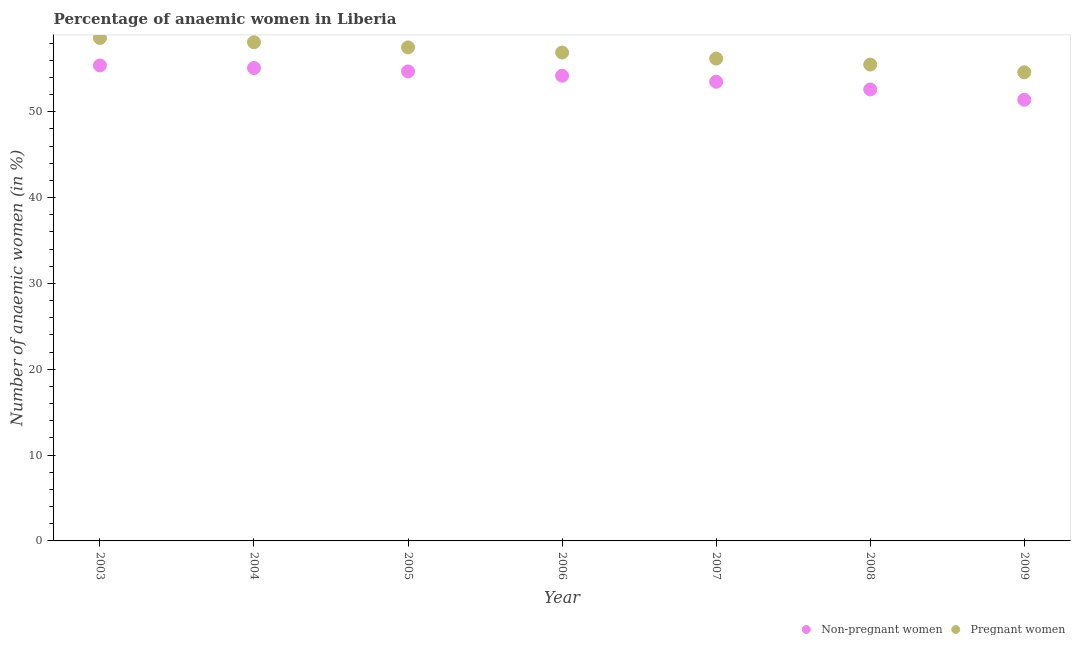How many different coloured dotlines are there?
Ensure brevity in your answer.  2. What is the percentage of pregnant anaemic women in 2003?
Provide a succinct answer. 58.6. Across all years, what is the maximum percentage of pregnant anaemic women?
Keep it short and to the point. 58.6. Across all years, what is the minimum percentage of non-pregnant anaemic women?
Your response must be concise. 51.4. What is the total percentage of pregnant anaemic women in the graph?
Offer a terse response. 397.4. What is the difference between the percentage of pregnant anaemic women in 2005 and that in 2009?
Ensure brevity in your answer.  2.9. What is the difference between the percentage of pregnant anaemic women in 2009 and the percentage of non-pregnant anaemic women in 2004?
Your answer should be very brief. -0.5. What is the average percentage of non-pregnant anaemic women per year?
Provide a succinct answer. 53.84. What is the ratio of the percentage of non-pregnant anaemic women in 2008 to that in 2009?
Provide a short and direct response. 1.02. Is the percentage of non-pregnant anaemic women in 2004 less than that in 2005?
Offer a very short reply. No. What is the difference between the highest and the second highest percentage of non-pregnant anaemic women?
Give a very brief answer. 0.3. In how many years, is the percentage of non-pregnant anaemic women greater than the average percentage of non-pregnant anaemic women taken over all years?
Keep it short and to the point. 4. Is the sum of the percentage of non-pregnant anaemic women in 2005 and 2008 greater than the maximum percentage of pregnant anaemic women across all years?
Offer a terse response. Yes. How many dotlines are there?
Your response must be concise. 2. How many years are there in the graph?
Offer a very short reply. 7. What is the difference between two consecutive major ticks on the Y-axis?
Keep it short and to the point. 10. Does the graph contain any zero values?
Give a very brief answer. No. Where does the legend appear in the graph?
Make the answer very short. Bottom right. What is the title of the graph?
Make the answer very short. Percentage of anaemic women in Liberia. Does "Goods" appear as one of the legend labels in the graph?
Ensure brevity in your answer.  No. What is the label or title of the Y-axis?
Keep it short and to the point. Number of anaemic women (in %). What is the Number of anaemic women (in %) in Non-pregnant women in 2003?
Offer a very short reply. 55.4. What is the Number of anaemic women (in %) of Pregnant women in 2003?
Give a very brief answer. 58.6. What is the Number of anaemic women (in %) of Non-pregnant women in 2004?
Your answer should be compact. 55.1. What is the Number of anaemic women (in %) in Pregnant women in 2004?
Give a very brief answer. 58.1. What is the Number of anaemic women (in %) of Non-pregnant women in 2005?
Ensure brevity in your answer.  54.7. What is the Number of anaemic women (in %) of Pregnant women in 2005?
Offer a terse response. 57.5. What is the Number of anaemic women (in %) of Non-pregnant women in 2006?
Ensure brevity in your answer.  54.2. What is the Number of anaemic women (in %) in Pregnant women in 2006?
Provide a short and direct response. 56.9. What is the Number of anaemic women (in %) in Non-pregnant women in 2007?
Offer a very short reply. 53.5. What is the Number of anaemic women (in %) of Pregnant women in 2007?
Provide a succinct answer. 56.2. What is the Number of anaemic women (in %) of Non-pregnant women in 2008?
Your response must be concise. 52.6. What is the Number of anaemic women (in %) in Pregnant women in 2008?
Keep it short and to the point. 55.5. What is the Number of anaemic women (in %) in Non-pregnant women in 2009?
Provide a short and direct response. 51.4. What is the Number of anaemic women (in %) in Pregnant women in 2009?
Offer a very short reply. 54.6. Across all years, what is the maximum Number of anaemic women (in %) of Non-pregnant women?
Give a very brief answer. 55.4. Across all years, what is the maximum Number of anaemic women (in %) of Pregnant women?
Your response must be concise. 58.6. Across all years, what is the minimum Number of anaemic women (in %) of Non-pregnant women?
Offer a terse response. 51.4. Across all years, what is the minimum Number of anaemic women (in %) of Pregnant women?
Provide a short and direct response. 54.6. What is the total Number of anaemic women (in %) in Non-pregnant women in the graph?
Your answer should be very brief. 376.9. What is the total Number of anaemic women (in %) of Pregnant women in the graph?
Ensure brevity in your answer.  397.4. What is the difference between the Number of anaemic women (in %) of Pregnant women in 2003 and that in 2004?
Your response must be concise. 0.5. What is the difference between the Number of anaemic women (in %) in Non-pregnant women in 2003 and that in 2005?
Make the answer very short. 0.7. What is the difference between the Number of anaemic women (in %) in Pregnant women in 2003 and that in 2006?
Keep it short and to the point. 1.7. What is the difference between the Number of anaemic women (in %) of Pregnant women in 2003 and that in 2007?
Make the answer very short. 2.4. What is the difference between the Number of anaemic women (in %) in Non-pregnant women in 2003 and that in 2009?
Give a very brief answer. 4. What is the difference between the Number of anaemic women (in %) in Pregnant women in 2003 and that in 2009?
Your answer should be very brief. 4. What is the difference between the Number of anaemic women (in %) in Non-pregnant women in 2004 and that in 2006?
Ensure brevity in your answer.  0.9. What is the difference between the Number of anaemic women (in %) in Pregnant women in 2004 and that in 2006?
Provide a succinct answer. 1.2. What is the difference between the Number of anaemic women (in %) of Non-pregnant women in 2004 and that in 2007?
Offer a terse response. 1.6. What is the difference between the Number of anaemic women (in %) of Non-pregnant women in 2004 and that in 2008?
Your response must be concise. 2.5. What is the difference between the Number of anaemic women (in %) of Pregnant women in 2004 and that in 2008?
Your answer should be compact. 2.6. What is the difference between the Number of anaemic women (in %) in Non-pregnant women in 2004 and that in 2009?
Keep it short and to the point. 3.7. What is the difference between the Number of anaemic women (in %) in Non-pregnant women in 2005 and that in 2006?
Your answer should be very brief. 0.5. What is the difference between the Number of anaemic women (in %) of Pregnant women in 2005 and that in 2007?
Give a very brief answer. 1.3. What is the difference between the Number of anaemic women (in %) of Non-pregnant women in 2005 and that in 2008?
Provide a short and direct response. 2.1. What is the difference between the Number of anaemic women (in %) of Pregnant women in 2005 and that in 2008?
Offer a very short reply. 2. What is the difference between the Number of anaemic women (in %) in Pregnant women in 2005 and that in 2009?
Provide a succinct answer. 2.9. What is the difference between the Number of anaemic women (in %) of Non-pregnant women in 2006 and that in 2007?
Give a very brief answer. 0.7. What is the difference between the Number of anaemic women (in %) of Pregnant women in 2006 and that in 2007?
Offer a terse response. 0.7. What is the difference between the Number of anaemic women (in %) of Non-pregnant women in 2007 and that in 2008?
Provide a short and direct response. 0.9. What is the difference between the Number of anaemic women (in %) of Pregnant women in 2007 and that in 2008?
Your answer should be very brief. 0.7. What is the difference between the Number of anaemic women (in %) in Non-pregnant women in 2007 and that in 2009?
Offer a very short reply. 2.1. What is the difference between the Number of anaemic women (in %) of Non-pregnant women in 2003 and the Number of anaemic women (in %) of Pregnant women in 2004?
Your answer should be compact. -2.7. What is the difference between the Number of anaemic women (in %) in Non-pregnant women in 2003 and the Number of anaemic women (in %) in Pregnant women in 2005?
Keep it short and to the point. -2.1. What is the difference between the Number of anaemic women (in %) in Non-pregnant women in 2003 and the Number of anaemic women (in %) in Pregnant women in 2007?
Your answer should be compact. -0.8. What is the difference between the Number of anaemic women (in %) of Non-pregnant women in 2004 and the Number of anaemic women (in %) of Pregnant women in 2005?
Make the answer very short. -2.4. What is the difference between the Number of anaemic women (in %) of Non-pregnant women in 2004 and the Number of anaemic women (in %) of Pregnant women in 2007?
Make the answer very short. -1.1. What is the difference between the Number of anaemic women (in %) of Non-pregnant women in 2004 and the Number of anaemic women (in %) of Pregnant women in 2008?
Your response must be concise. -0.4. What is the difference between the Number of anaemic women (in %) in Non-pregnant women in 2005 and the Number of anaemic women (in %) in Pregnant women in 2006?
Your answer should be compact. -2.2. What is the difference between the Number of anaemic women (in %) of Non-pregnant women in 2005 and the Number of anaemic women (in %) of Pregnant women in 2007?
Provide a succinct answer. -1.5. What is the difference between the Number of anaemic women (in %) of Non-pregnant women in 2005 and the Number of anaemic women (in %) of Pregnant women in 2008?
Offer a very short reply. -0.8. What is the difference between the Number of anaemic women (in %) of Non-pregnant women in 2006 and the Number of anaemic women (in %) of Pregnant women in 2007?
Provide a succinct answer. -2. What is the difference between the Number of anaemic women (in %) in Non-pregnant women in 2007 and the Number of anaemic women (in %) in Pregnant women in 2009?
Make the answer very short. -1.1. What is the average Number of anaemic women (in %) of Non-pregnant women per year?
Your response must be concise. 53.84. What is the average Number of anaemic women (in %) of Pregnant women per year?
Provide a succinct answer. 56.77. In the year 2006, what is the difference between the Number of anaemic women (in %) of Non-pregnant women and Number of anaemic women (in %) of Pregnant women?
Make the answer very short. -2.7. In the year 2009, what is the difference between the Number of anaemic women (in %) of Non-pregnant women and Number of anaemic women (in %) of Pregnant women?
Offer a very short reply. -3.2. What is the ratio of the Number of anaemic women (in %) of Non-pregnant women in 2003 to that in 2004?
Provide a succinct answer. 1.01. What is the ratio of the Number of anaemic women (in %) in Pregnant women in 2003 to that in 2004?
Give a very brief answer. 1.01. What is the ratio of the Number of anaemic women (in %) in Non-pregnant women in 2003 to that in 2005?
Make the answer very short. 1.01. What is the ratio of the Number of anaemic women (in %) in Pregnant women in 2003 to that in 2005?
Your answer should be compact. 1.02. What is the ratio of the Number of anaemic women (in %) in Non-pregnant women in 2003 to that in 2006?
Give a very brief answer. 1.02. What is the ratio of the Number of anaemic women (in %) of Pregnant women in 2003 to that in 2006?
Your answer should be very brief. 1.03. What is the ratio of the Number of anaemic women (in %) of Non-pregnant women in 2003 to that in 2007?
Keep it short and to the point. 1.04. What is the ratio of the Number of anaemic women (in %) in Pregnant women in 2003 to that in 2007?
Give a very brief answer. 1.04. What is the ratio of the Number of anaemic women (in %) of Non-pregnant women in 2003 to that in 2008?
Ensure brevity in your answer.  1.05. What is the ratio of the Number of anaemic women (in %) of Pregnant women in 2003 to that in 2008?
Offer a very short reply. 1.06. What is the ratio of the Number of anaemic women (in %) of Non-pregnant women in 2003 to that in 2009?
Offer a very short reply. 1.08. What is the ratio of the Number of anaemic women (in %) in Pregnant women in 2003 to that in 2009?
Offer a terse response. 1.07. What is the ratio of the Number of anaemic women (in %) in Non-pregnant women in 2004 to that in 2005?
Offer a very short reply. 1.01. What is the ratio of the Number of anaemic women (in %) in Pregnant women in 2004 to that in 2005?
Ensure brevity in your answer.  1.01. What is the ratio of the Number of anaemic women (in %) in Non-pregnant women in 2004 to that in 2006?
Offer a terse response. 1.02. What is the ratio of the Number of anaemic women (in %) of Pregnant women in 2004 to that in 2006?
Your answer should be compact. 1.02. What is the ratio of the Number of anaemic women (in %) of Non-pregnant women in 2004 to that in 2007?
Keep it short and to the point. 1.03. What is the ratio of the Number of anaemic women (in %) in Pregnant women in 2004 to that in 2007?
Offer a terse response. 1.03. What is the ratio of the Number of anaemic women (in %) of Non-pregnant women in 2004 to that in 2008?
Make the answer very short. 1.05. What is the ratio of the Number of anaemic women (in %) in Pregnant women in 2004 to that in 2008?
Offer a very short reply. 1.05. What is the ratio of the Number of anaemic women (in %) in Non-pregnant women in 2004 to that in 2009?
Ensure brevity in your answer.  1.07. What is the ratio of the Number of anaemic women (in %) in Pregnant women in 2004 to that in 2009?
Your answer should be compact. 1.06. What is the ratio of the Number of anaemic women (in %) of Non-pregnant women in 2005 to that in 2006?
Your response must be concise. 1.01. What is the ratio of the Number of anaemic women (in %) in Pregnant women in 2005 to that in 2006?
Your answer should be very brief. 1.01. What is the ratio of the Number of anaemic women (in %) in Non-pregnant women in 2005 to that in 2007?
Provide a short and direct response. 1.02. What is the ratio of the Number of anaemic women (in %) of Pregnant women in 2005 to that in 2007?
Make the answer very short. 1.02. What is the ratio of the Number of anaemic women (in %) in Non-pregnant women in 2005 to that in 2008?
Provide a short and direct response. 1.04. What is the ratio of the Number of anaemic women (in %) in Pregnant women in 2005 to that in 2008?
Your answer should be compact. 1.04. What is the ratio of the Number of anaemic women (in %) of Non-pregnant women in 2005 to that in 2009?
Provide a short and direct response. 1.06. What is the ratio of the Number of anaemic women (in %) of Pregnant women in 2005 to that in 2009?
Keep it short and to the point. 1.05. What is the ratio of the Number of anaemic women (in %) in Non-pregnant women in 2006 to that in 2007?
Make the answer very short. 1.01. What is the ratio of the Number of anaemic women (in %) of Pregnant women in 2006 to that in 2007?
Keep it short and to the point. 1.01. What is the ratio of the Number of anaemic women (in %) in Non-pregnant women in 2006 to that in 2008?
Keep it short and to the point. 1.03. What is the ratio of the Number of anaemic women (in %) in Pregnant women in 2006 to that in 2008?
Offer a very short reply. 1.03. What is the ratio of the Number of anaemic women (in %) in Non-pregnant women in 2006 to that in 2009?
Provide a short and direct response. 1.05. What is the ratio of the Number of anaemic women (in %) of Pregnant women in 2006 to that in 2009?
Provide a short and direct response. 1.04. What is the ratio of the Number of anaemic women (in %) of Non-pregnant women in 2007 to that in 2008?
Provide a succinct answer. 1.02. What is the ratio of the Number of anaemic women (in %) of Pregnant women in 2007 to that in 2008?
Your response must be concise. 1.01. What is the ratio of the Number of anaemic women (in %) in Non-pregnant women in 2007 to that in 2009?
Your answer should be compact. 1.04. What is the ratio of the Number of anaemic women (in %) in Pregnant women in 2007 to that in 2009?
Give a very brief answer. 1.03. What is the ratio of the Number of anaemic women (in %) in Non-pregnant women in 2008 to that in 2009?
Provide a short and direct response. 1.02. What is the ratio of the Number of anaemic women (in %) in Pregnant women in 2008 to that in 2009?
Keep it short and to the point. 1.02. 